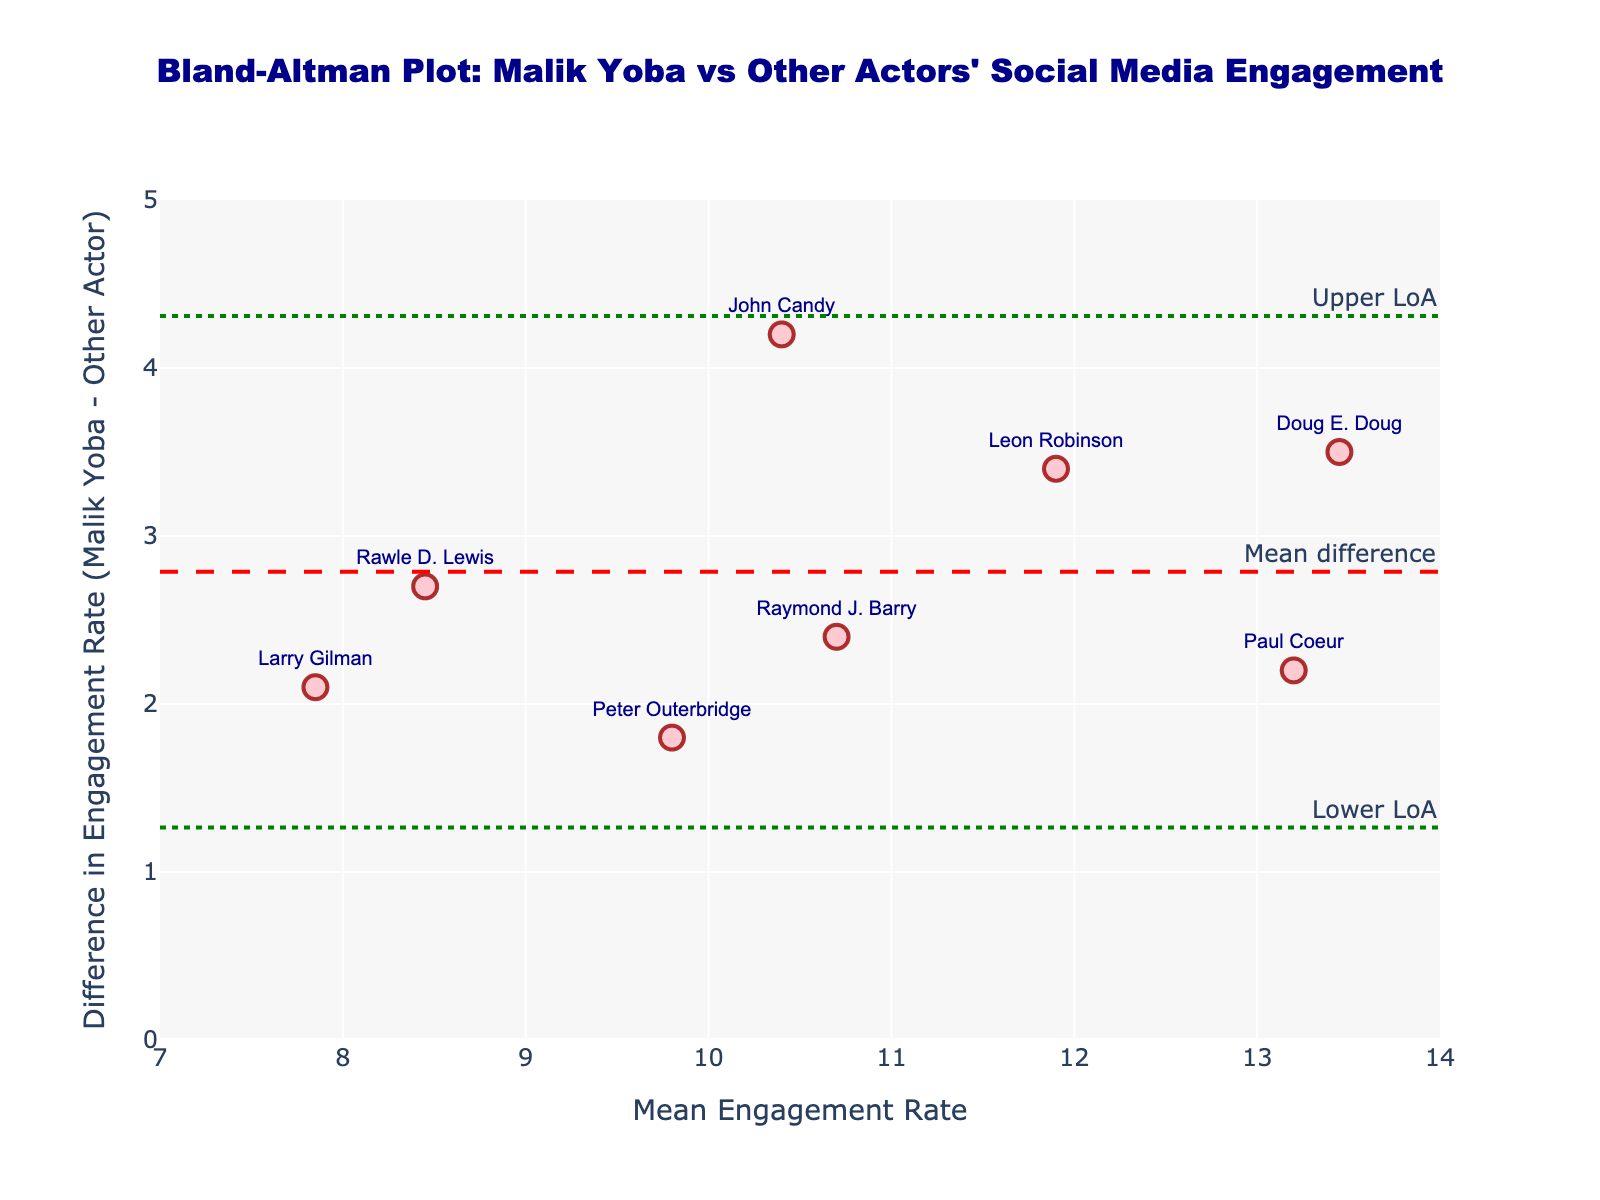What is the title of the plot? The title of the plot is generally placed at the top of the figure and is prominently displayed to describe what the plot represents.
Answer: Bland-Altman Plot: Malik Yoba vs Other Actors' Social Media Engagement What do the x-axis and y-axis represent in this plot? The x-axis and y-axis are labeled to specify what each axis represents. In this plot, the x-axis represents the "Mean Engagement Rate" while the y-axis represents the "Difference in Engagement Rate".
Answer: x-axis: Mean Engagement Rate, y-axis: Difference in Engagement Rate How many data points are plotted on the Bland-Altman plot? Each point in the plot represents an actor, and counting these points gives the total number of data points in the plot. There are 8 actors listed in the data.
Answer: 8 What is the color and shape of the markers used in the scatter plot? The appearance of markers in the scatter plot is specified; the markers are of a certain color and shape to distinguish them from other elements on the plot. Here, the markers are circular and pink.
Answer: Pink circles Who has the highest difference in engagement rates, and how can you tell? Each actor's difference in engagement rates can be determined by the y-value of the corresponding point. The actor with the highest y-value has the highest difference. Doug E. Doug has the highest y-value.
Answer: Doug E. Doug Which two actors have the closest average engagement rates? To find the two actors with the closest average engagement rates, look for the points that are nearest to each other on the x-axis. John Candy and Raymond J. Barry are closest on the x-axis.
Answer: John Candy and Raymond J. Barry What is the mean difference line, and what does it represent? The mean difference line is marked by a horizontal line on the plot. It represents the average difference in engagement rates between Malik Yoba and the other actors. This line helps in understanding the overall bias.
Answer: A horizontal red dashed line Can you identify the limits of agreement on this plot? The limits of agreement are represented by two horizontal lines at specific y-values, calculated as the mean difference ± 1.96 times the standard deviation of differences. These lines are dotted and colored green.
Answer: Lower and upper green dotted lines What is the range of the y-axis used in the plot? The range of the y-axis is specified in the plot's layout to help interpret the spread of the data points. Here, it ranges from 0 to 5.
Answer: 0 to 5 Which actor falls closest to the mean difference line? The actor closest to the mean difference line on the y-axis can be identified by finding the point nearest to this line. Leon Robinson is closest to the mean difference line.
Answer: Leon Robinson 